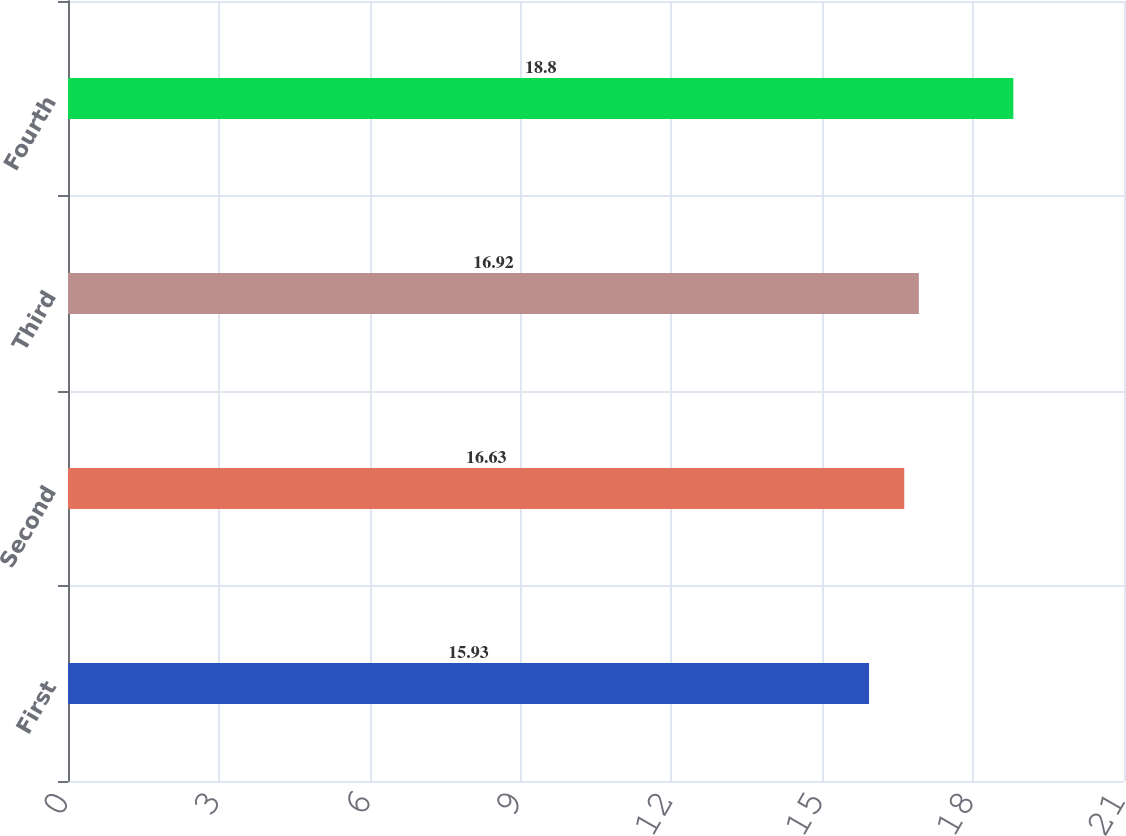<chart> <loc_0><loc_0><loc_500><loc_500><bar_chart><fcel>First<fcel>Second<fcel>Third<fcel>Fourth<nl><fcel>15.93<fcel>16.63<fcel>16.92<fcel>18.8<nl></chart> 